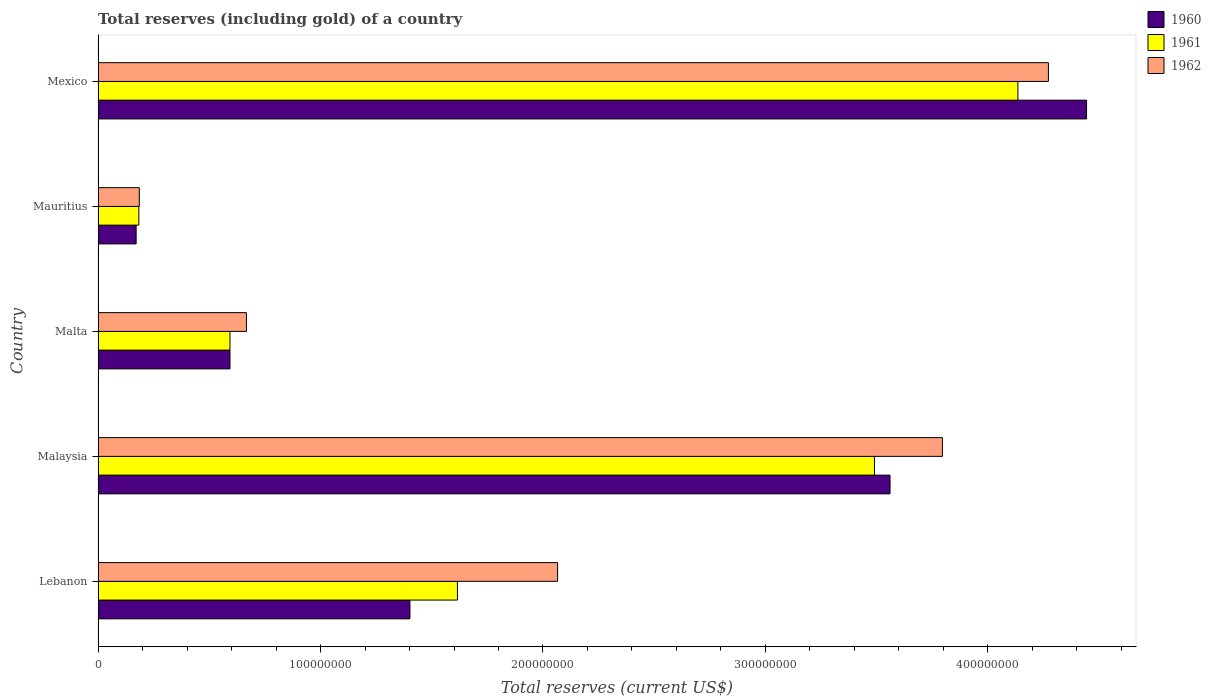How many groups of bars are there?
Offer a terse response. 5. Are the number of bars per tick equal to the number of legend labels?
Your answer should be very brief. Yes. What is the label of the 2nd group of bars from the top?
Offer a very short reply. Mauritius. In how many cases, is the number of bars for a given country not equal to the number of legend labels?
Give a very brief answer. 0. What is the total reserves (including gold) in 1960 in Malaysia?
Make the answer very short. 3.56e+08. Across all countries, what is the maximum total reserves (including gold) in 1960?
Make the answer very short. 4.44e+08. Across all countries, what is the minimum total reserves (including gold) in 1962?
Offer a very short reply. 1.86e+07. In which country was the total reserves (including gold) in 1961 maximum?
Your response must be concise. Mexico. In which country was the total reserves (including gold) in 1961 minimum?
Provide a succinct answer. Mauritius. What is the total total reserves (including gold) in 1960 in the graph?
Your answer should be compact. 1.02e+09. What is the difference between the total reserves (including gold) in 1961 in Lebanon and that in Mexico?
Give a very brief answer. -2.52e+08. What is the difference between the total reserves (including gold) in 1960 in Malaysia and the total reserves (including gold) in 1962 in Mexico?
Make the answer very short. -7.12e+07. What is the average total reserves (including gold) in 1961 per country?
Provide a succinct answer. 2.00e+08. What is the difference between the total reserves (including gold) in 1962 and total reserves (including gold) in 1961 in Lebanon?
Keep it short and to the point. 4.50e+07. What is the ratio of the total reserves (including gold) in 1961 in Lebanon to that in Mauritius?
Ensure brevity in your answer.  8.81. Is the total reserves (including gold) in 1960 in Lebanon less than that in Malta?
Provide a succinct answer. No. Is the difference between the total reserves (including gold) in 1962 in Lebanon and Malta greater than the difference between the total reserves (including gold) in 1961 in Lebanon and Malta?
Your answer should be compact. Yes. What is the difference between the highest and the second highest total reserves (including gold) in 1961?
Give a very brief answer. 6.45e+07. What is the difference between the highest and the lowest total reserves (including gold) in 1961?
Your response must be concise. 3.95e+08. Is the sum of the total reserves (including gold) in 1961 in Malta and Mauritius greater than the maximum total reserves (including gold) in 1960 across all countries?
Your response must be concise. No. What does the 1st bar from the top in Malaysia represents?
Your answer should be very brief. 1962. What does the 3rd bar from the bottom in Malta represents?
Provide a short and direct response. 1962. Is it the case that in every country, the sum of the total reserves (including gold) in 1962 and total reserves (including gold) in 1960 is greater than the total reserves (including gold) in 1961?
Provide a succinct answer. Yes. Are all the bars in the graph horizontal?
Your answer should be very brief. Yes. How many countries are there in the graph?
Provide a succinct answer. 5. Does the graph contain any zero values?
Make the answer very short. No. How are the legend labels stacked?
Give a very brief answer. Vertical. What is the title of the graph?
Your answer should be very brief. Total reserves (including gold) of a country. Does "1999" appear as one of the legend labels in the graph?
Give a very brief answer. No. What is the label or title of the X-axis?
Provide a short and direct response. Total reserves (current US$). What is the Total reserves (current US$) of 1960 in Lebanon?
Make the answer very short. 1.40e+08. What is the Total reserves (current US$) in 1961 in Lebanon?
Give a very brief answer. 1.62e+08. What is the Total reserves (current US$) in 1962 in Lebanon?
Make the answer very short. 2.07e+08. What is the Total reserves (current US$) in 1960 in Malaysia?
Offer a very short reply. 3.56e+08. What is the Total reserves (current US$) of 1961 in Malaysia?
Make the answer very short. 3.49e+08. What is the Total reserves (current US$) of 1962 in Malaysia?
Give a very brief answer. 3.80e+08. What is the Total reserves (current US$) in 1960 in Malta?
Ensure brevity in your answer.  5.93e+07. What is the Total reserves (current US$) of 1961 in Malta?
Your response must be concise. 5.93e+07. What is the Total reserves (current US$) in 1962 in Malta?
Provide a short and direct response. 6.67e+07. What is the Total reserves (current US$) of 1960 in Mauritius?
Provide a succinct answer. 1.71e+07. What is the Total reserves (current US$) in 1961 in Mauritius?
Your answer should be very brief. 1.83e+07. What is the Total reserves (current US$) of 1962 in Mauritius?
Your answer should be compact. 1.86e+07. What is the Total reserves (current US$) in 1960 in Mexico?
Make the answer very short. 4.44e+08. What is the Total reserves (current US$) in 1961 in Mexico?
Your response must be concise. 4.13e+08. What is the Total reserves (current US$) in 1962 in Mexico?
Your answer should be compact. 4.27e+08. Across all countries, what is the maximum Total reserves (current US$) in 1960?
Offer a very short reply. 4.44e+08. Across all countries, what is the maximum Total reserves (current US$) of 1961?
Your answer should be compact. 4.13e+08. Across all countries, what is the maximum Total reserves (current US$) in 1962?
Your response must be concise. 4.27e+08. Across all countries, what is the minimum Total reserves (current US$) in 1960?
Your answer should be compact. 1.71e+07. Across all countries, what is the minimum Total reserves (current US$) in 1961?
Offer a very short reply. 1.83e+07. Across all countries, what is the minimum Total reserves (current US$) in 1962?
Your response must be concise. 1.86e+07. What is the total Total reserves (current US$) in 1960 in the graph?
Keep it short and to the point. 1.02e+09. What is the total Total reserves (current US$) of 1961 in the graph?
Your response must be concise. 1.00e+09. What is the total Total reserves (current US$) of 1962 in the graph?
Offer a very short reply. 1.10e+09. What is the difference between the Total reserves (current US$) of 1960 in Lebanon and that in Malaysia?
Your answer should be very brief. -2.16e+08. What is the difference between the Total reserves (current US$) of 1961 in Lebanon and that in Malaysia?
Keep it short and to the point. -1.87e+08. What is the difference between the Total reserves (current US$) in 1962 in Lebanon and that in Malaysia?
Your response must be concise. -1.73e+08. What is the difference between the Total reserves (current US$) of 1960 in Lebanon and that in Malta?
Keep it short and to the point. 8.09e+07. What is the difference between the Total reserves (current US$) in 1961 in Lebanon and that in Malta?
Give a very brief answer. 1.02e+08. What is the difference between the Total reserves (current US$) in 1962 in Lebanon and that in Malta?
Offer a terse response. 1.40e+08. What is the difference between the Total reserves (current US$) in 1960 in Lebanon and that in Mauritius?
Your response must be concise. 1.23e+08. What is the difference between the Total reserves (current US$) in 1961 in Lebanon and that in Mauritius?
Your answer should be compact. 1.43e+08. What is the difference between the Total reserves (current US$) of 1962 in Lebanon and that in Mauritius?
Your answer should be compact. 1.88e+08. What is the difference between the Total reserves (current US$) of 1960 in Lebanon and that in Mexico?
Your response must be concise. -3.04e+08. What is the difference between the Total reserves (current US$) of 1961 in Lebanon and that in Mexico?
Your answer should be very brief. -2.52e+08. What is the difference between the Total reserves (current US$) in 1962 in Lebanon and that in Mexico?
Your answer should be compact. -2.21e+08. What is the difference between the Total reserves (current US$) of 1960 in Malaysia and that in Malta?
Offer a terse response. 2.97e+08. What is the difference between the Total reserves (current US$) of 1961 in Malaysia and that in Malta?
Offer a terse response. 2.90e+08. What is the difference between the Total reserves (current US$) of 1962 in Malaysia and that in Malta?
Give a very brief answer. 3.13e+08. What is the difference between the Total reserves (current US$) in 1960 in Malaysia and that in Mauritius?
Offer a very short reply. 3.39e+08. What is the difference between the Total reserves (current US$) of 1961 in Malaysia and that in Mauritius?
Your response must be concise. 3.31e+08. What is the difference between the Total reserves (current US$) in 1962 in Malaysia and that in Mauritius?
Keep it short and to the point. 3.61e+08. What is the difference between the Total reserves (current US$) of 1960 in Malaysia and that in Mexico?
Provide a short and direct response. -8.83e+07. What is the difference between the Total reserves (current US$) in 1961 in Malaysia and that in Mexico?
Make the answer very short. -6.45e+07. What is the difference between the Total reserves (current US$) in 1962 in Malaysia and that in Mexico?
Your answer should be very brief. -4.77e+07. What is the difference between the Total reserves (current US$) in 1960 in Malta and that in Mauritius?
Your answer should be compact. 4.22e+07. What is the difference between the Total reserves (current US$) in 1961 in Malta and that in Mauritius?
Provide a short and direct response. 4.10e+07. What is the difference between the Total reserves (current US$) of 1962 in Malta and that in Mauritius?
Provide a short and direct response. 4.82e+07. What is the difference between the Total reserves (current US$) in 1960 in Malta and that in Mexico?
Give a very brief answer. -3.85e+08. What is the difference between the Total reserves (current US$) of 1961 in Malta and that in Mexico?
Keep it short and to the point. -3.54e+08. What is the difference between the Total reserves (current US$) of 1962 in Malta and that in Mexico?
Your answer should be compact. -3.60e+08. What is the difference between the Total reserves (current US$) of 1960 in Mauritius and that in Mexico?
Provide a short and direct response. -4.27e+08. What is the difference between the Total reserves (current US$) of 1961 in Mauritius and that in Mexico?
Ensure brevity in your answer.  -3.95e+08. What is the difference between the Total reserves (current US$) in 1962 in Mauritius and that in Mexico?
Give a very brief answer. -4.09e+08. What is the difference between the Total reserves (current US$) of 1960 in Lebanon and the Total reserves (current US$) of 1961 in Malaysia?
Your response must be concise. -2.09e+08. What is the difference between the Total reserves (current US$) in 1960 in Lebanon and the Total reserves (current US$) in 1962 in Malaysia?
Offer a terse response. -2.39e+08. What is the difference between the Total reserves (current US$) in 1961 in Lebanon and the Total reserves (current US$) in 1962 in Malaysia?
Provide a succinct answer. -2.18e+08. What is the difference between the Total reserves (current US$) in 1960 in Lebanon and the Total reserves (current US$) in 1961 in Malta?
Provide a succinct answer. 8.09e+07. What is the difference between the Total reserves (current US$) of 1960 in Lebanon and the Total reserves (current US$) of 1962 in Malta?
Offer a very short reply. 7.35e+07. What is the difference between the Total reserves (current US$) of 1961 in Lebanon and the Total reserves (current US$) of 1962 in Malta?
Your answer should be very brief. 9.49e+07. What is the difference between the Total reserves (current US$) of 1960 in Lebanon and the Total reserves (current US$) of 1961 in Mauritius?
Offer a very short reply. 1.22e+08. What is the difference between the Total reserves (current US$) in 1960 in Lebanon and the Total reserves (current US$) in 1962 in Mauritius?
Provide a short and direct response. 1.22e+08. What is the difference between the Total reserves (current US$) of 1961 in Lebanon and the Total reserves (current US$) of 1962 in Mauritius?
Make the answer very short. 1.43e+08. What is the difference between the Total reserves (current US$) of 1960 in Lebanon and the Total reserves (current US$) of 1961 in Mexico?
Keep it short and to the point. -2.73e+08. What is the difference between the Total reserves (current US$) in 1960 in Lebanon and the Total reserves (current US$) in 1962 in Mexico?
Offer a terse response. -2.87e+08. What is the difference between the Total reserves (current US$) of 1961 in Lebanon and the Total reserves (current US$) of 1962 in Mexico?
Offer a terse response. -2.66e+08. What is the difference between the Total reserves (current US$) of 1960 in Malaysia and the Total reserves (current US$) of 1961 in Malta?
Your answer should be compact. 2.97e+08. What is the difference between the Total reserves (current US$) in 1960 in Malaysia and the Total reserves (current US$) in 1962 in Malta?
Your answer should be very brief. 2.89e+08. What is the difference between the Total reserves (current US$) in 1961 in Malaysia and the Total reserves (current US$) in 1962 in Malta?
Offer a very short reply. 2.82e+08. What is the difference between the Total reserves (current US$) in 1960 in Malaysia and the Total reserves (current US$) in 1961 in Mauritius?
Give a very brief answer. 3.38e+08. What is the difference between the Total reserves (current US$) in 1960 in Malaysia and the Total reserves (current US$) in 1962 in Mauritius?
Ensure brevity in your answer.  3.37e+08. What is the difference between the Total reserves (current US$) of 1961 in Malaysia and the Total reserves (current US$) of 1962 in Mauritius?
Provide a succinct answer. 3.30e+08. What is the difference between the Total reserves (current US$) in 1960 in Malaysia and the Total reserves (current US$) in 1961 in Mexico?
Make the answer very short. -5.75e+07. What is the difference between the Total reserves (current US$) of 1960 in Malaysia and the Total reserves (current US$) of 1962 in Mexico?
Offer a very short reply. -7.12e+07. What is the difference between the Total reserves (current US$) of 1961 in Malaysia and the Total reserves (current US$) of 1962 in Mexico?
Provide a succinct answer. -7.82e+07. What is the difference between the Total reserves (current US$) in 1960 in Malta and the Total reserves (current US$) in 1961 in Mauritius?
Provide a succinct answer. 4.10e+07. What is the difference between the Total reserves (current US$) of 1960 in Malta and the Total reserves (current US$) of 1962 in Mauritius?
Your answer should be very brief. 4.08e+07. What is the difference between the Total reserves (current US$) in 1961 in Malta and the Total reserves (current US$) in 1962 in Mauritius?
Your answer should be compact. 4.08e+07. What is the difference between the Total reserves (current US$) in 1960 in Malta and the Total reserves (current US$) in 1961 in Mexico?
Provide a succinct answer. -3.54e+08. What is the difference between the Total reserves (current US$) of 1960 in Malta and the Total reserves (current US$) of 1962 in Mexico?
Ensure brevity in your answer.  -3.68e+08. What is the difference between the Total reserves (current US$) of 1961 in Malta and the Total reserves (current US$) of 1962 in Mexico?
Provide a succinct answer. -3.68e+08. What is the difference between the Total reserves (current US$) in 1960 in Mauritius and the Total reserves (current US$) in 1961 in Mexico?
Your answer should be compact. -3.96e+08. What is the difference between the Total reserves (current US$) in 1960 in Mauritius and the Total reserves (current US$) in 1962 in Mexico?
Provide a succinct answer. -4.10e+08. What is the difference between the Total reserves (current US$) in 1961 in Mauritius and the Total reserves (current US$) in 1962 in Mexico?
Give a very brief answer. -4.09e+08. What is the average Total reserves (current US$) in 1960 per country?
Keep it short and to the point. 2.03e+08. What is the average Total reserves (current US$) in 1961 per country?
Ensure brevity in your answer.  2.00e+08. What is the average Total reserves (current US$) of 1962 per country?
Offer a very short reply. 2.20e+08. What is the difference between the Total reserves (current US$) of 1960 and Total reserves (current US$) of 1961 in Lebanon?
Offer a terse response. -2.14e+07. What is the difference between the Total reserves (current US$) in 1960 and Total reserves (current US$) in 1962 in Lebanon?
Offer a very short reply. -6.64e+07. What is the difference between the Total reserves (current US$) of 1961 and Total reserves (current US$) of 1962 in Lebanon?
Offer a terse response. -4.50e+07. What is the difference between the Total reserves (current US$) of 1960 and Total reserves (current US$) of 1961 in Malaysia?
Keep it short and to the point. 7.00e+06. What is the difference between the Total reserves (current US$) in 1960 and Total reserves (current US$) in 1962 in Malaysia?
Make the answer very short. -2.35e+07. What is the difference between the Total reserves (current US$) of 1961 and Total reserves (current US$) of 1962 in Malaysia?
Your response must be concise. -3.05e+07. What is the difference between the Total reserves (current US$) in 1960 and Total reserves (current US$) in 1962 in Malta?
Ensure brevity in your answer.  -7.40e+06. What is the difference between the Total reserves (current US$) of 1961 and Total reserves (current US$) of 1962 in Malta?
Your answer should be very brief. -7.40e+06. What is the difference between the Total reserves (current US$) of 1960 and Total reserves (current US$) of 1961 in Mauritius?
Ensure brevity in your answer.  -1.22e+06. What is the difference between the Total reserves (current US$) in 1960 and Total reserves (current US$) in 1962 in Mauritius?
Your answer should be compact. -1.43e+06. What is the difference between the Total reserves (current US$) of 1960 and Total reserves (current US$) of 1961 in Mexico?
Your response must be concise. 3.09e+07. What is the difference between the Total reserves (current US$) in 1960 and Total reserves (current US$) in 1962 in Mexico?
Make the answer very short. 1.71e+07. What is the difference between the Total reserves (current US$) in 1961 and Total reserves (current US$) in 1962 in Mexico?
Your answer should be compact. -1.37e+07. What is the ratio of the Total reserves (current US$) in 1960 in Lebanon to that in Malaysia?
Provide a short and direct response. 0.39. What is the ratio of the Total reserves (current US$) in 1961 in Lebanon to that in Malaysia?
Make the answer very short. 0.46. What is the ratio of the Total reserves (current US$) in 1962 in Lebanon to that in Malaysia?
Your response must be concise. 0.54. What is the ratio of the Total reserves (current US$) of 1960 in Lebanon to that in Malta?
Give a very brief answer. 2.36. What is the ratio of the Total reserves (current US$) of 1961 in Lebanon to that in Malta?
Provide a succinct answer. 2.72. What is the ratio of the Total reserves (current US$) of 1962 in Lebanon to that in Malta?
Make the answer very short. 3.1. What is the ratio of the Total reserves (current US$) in 1960 in Lebanon to that in Mauritius?
Provide a succinct answer. 8.19. What is the ratio of the Total reserves (current US$) in 1961 in Lebanon to that in Mauritius?
Your answer should be compact. 8.81. What is the ratio of the Total reserves (current US$) in 1962 in Lebanon to that in Mauritius?
Provide a short and direct response. 11.14. What is the ratio of the Total reserves (current US$) in 1960 in Lebanon to that in Mexico?
Your answer should be compact. 0.32. What is the ratio of the Total reserves (current US$) in 1961 in Lebanon to that in Mexico?
Offer a very short reply. 0.39. What is the ratio of the Total reserves (current US$) of 1962 in Lebanon to that in Mexico?
Give a very brief answer. 0.48. What is the ratio of the Total reserves (current US$) in 1960 in Malaysia to that in Malta?
Offer a very short reply. 6. What is the ratio of the Total reserves (current US$) in 1961 in Malaysia to that in Malta?
Your answer should be very brief. 5.89. What is the ratio of the Total reserves (current US$) of 1962 in Malaysia to that in Malta?
Give a very brief answer. 5.69. What is the ratio of the Total reserves (current US$) of 1960 in Malaysia to that in Mauritius?
Your answer should be very brief. 20.79. What is the ratio of the Total reserves (current US$) of 1961 in Malaysia to that in Mauritius?
Your response must be concise. 19.03. What is the ratio of the Total reserves (current US$) in 1962 in Malaysia to that in Mauritius?
Make the answer very short. 20.46. What is the ratio of the Total reserves (current US$) in 1960 in Malaysia to that in Mexico?
Your answer should be compact. 0.8. What is the ratio of the Total reserves (current US$) in 1961 in Malaysia to that in Mexico?
Offer a terse response. 0.84. What is the ratio of the Total reserves (current US$) in 1962 in Malaysia to that in Mexico?
Provide a succinct answer. 0.89. What is the ratio of the Total reserves (current US$) of 1960 in Malta to that in Mauritius?
Offer a very short reply. 3.46. What is the ratio of the Total reserves (current US$) in 1961 in Malta to that in Mauritius?
Provide a short and direct response. 3.23. What is the ratio of the Total reserves (current US$) in 1962 in Malta to that in Mauritius?
Ensure brevity in your answer.  3.6. What is the ratio of the Total reserves (current US$) of 1960 in Malta to that in Mexico?
Ensure brevity in your answer.  0.13. What is the ratio of the Total reserves (current US$) of 1961 in Malta to that in Mexico?
Offer a terse response. 0.14. What is the ratio of the Total reserves (current US$) in 1962 in Malta to that in Mexico?
Make the answer very short. 0.16. What is the ratio of the Total reserves (current US$) of 1960 in Mauritius to that in Mexico?
Ensure brevity in your answer.  0.04. What is the ratio of the Total reserves (current US$) in 1961 in Mauritius to that in Mexico?
Your answer should be compact. 0.04. What is the ratio of the Total reserves (current US$) of 1962 in Mauritius to that in Mexico?
Ensure brevity in your answer.  0.04. What is the difference between the highest and the second highest Total reserves (current US$) of 1960?
Your answer should be very brief. 8.83e+07. What is the difference between the highest and the second highest Total reserves (current US$) in 1961?
Your answer should be very brief. 6.45e+07. What is the difference between the highest and the second highest Total reserves (current US$) in 1962?
Give a very brief answer. 4.77e+07. What is the difference between the highest and the lowest Total reserves (current US$) in 1960?
Make the answer very short. 4.27e+08. What is the difference between the highest and the lowest Total reserves (current US$) in 1961?
Provide a short and direct response. 3.95e+08. What is the difference between the highest and the lowest Total reserves (current US$) in 1962?
Provide a short and direct response. 4.09e+08. 